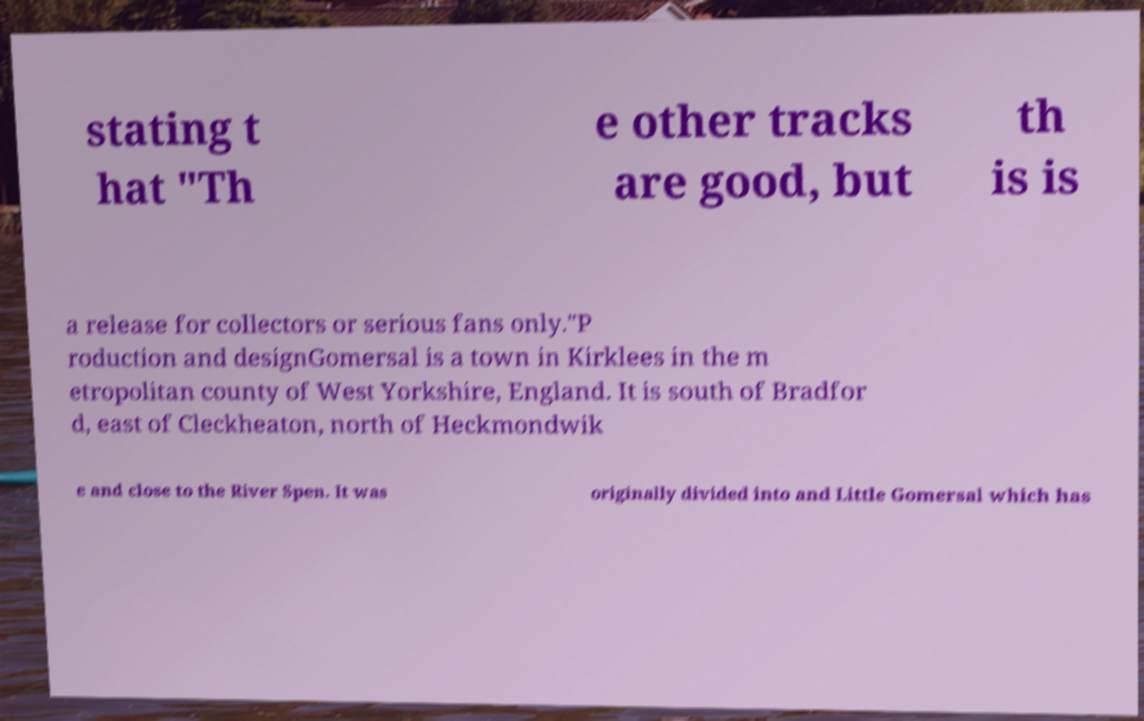For documentation purposes, I need the text within this image transcribed. Could you provide that? stating t hat "Th e other tracks are good, but th is is a release for collectors or serious fans only."P roduction and designGomersal is a town in Kirklees in the m etropolitan county of West Yorkshire, England. It is south of Bradfor d, east of Cleckheaton, north of Heckmondwik e and close to the River Spen. It was originally divided into and Little Gomersal which has 